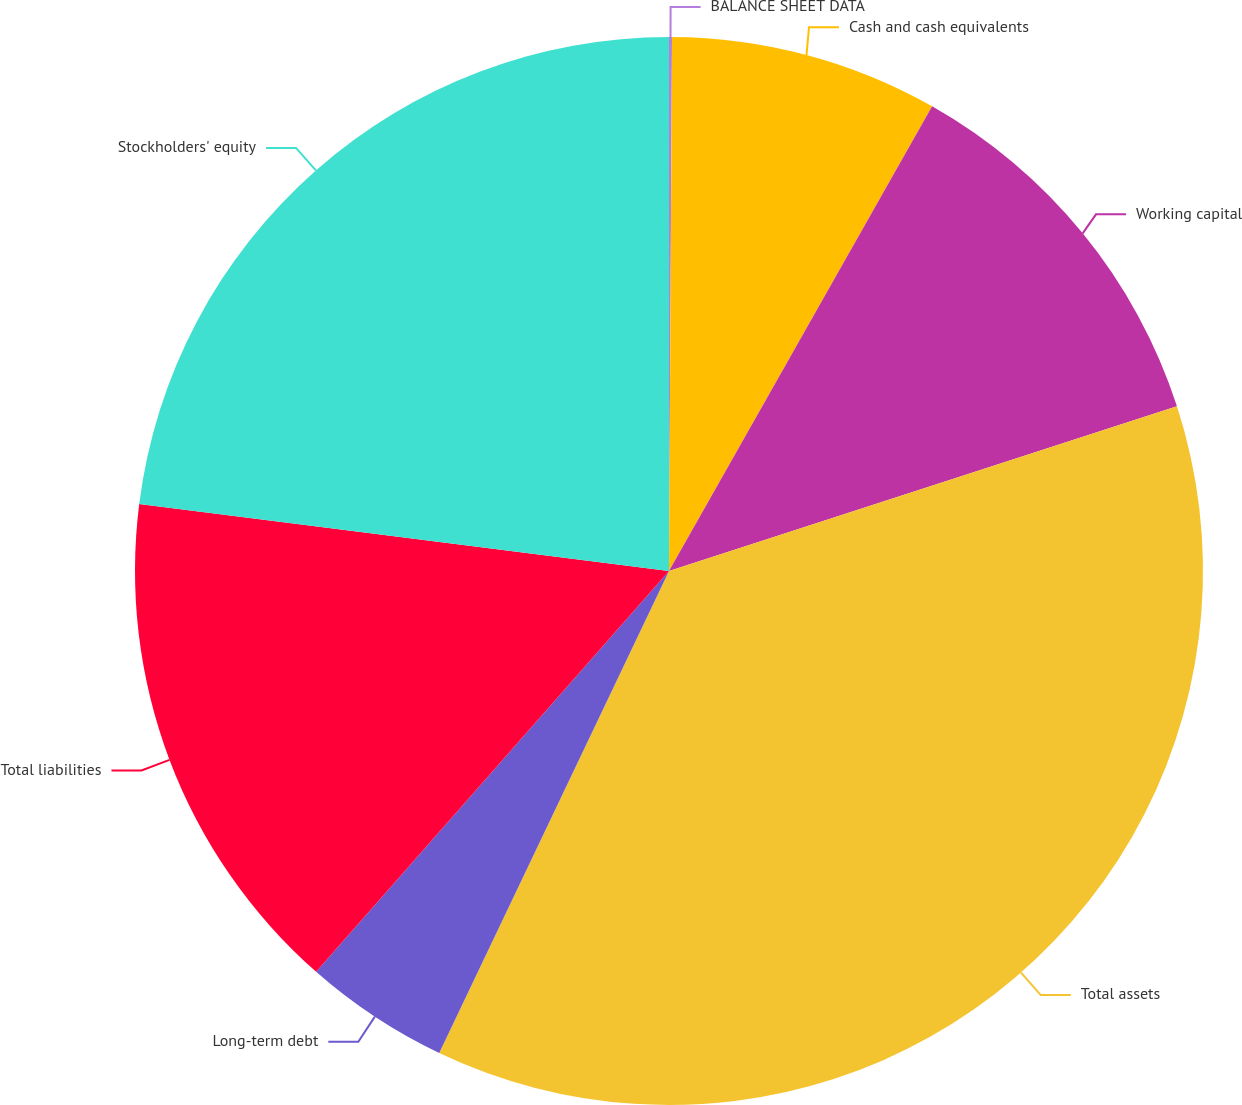Convert chart to OTSL. <chart><loc_0><loc_0><loc_500><loc_500><pie_chart><fcel>BALANCE SHEET DATA<fcel>Cash and cash equivalents<fcel>Working capital<fcel>Total assets<fcel>Long-term debt<fcel>Total liabilities<fcel>Stockholders' equity<nl><fcel>0.09%<fcel>8.11%<fcel>11.81%<fcel>37.07%<fcel>4.41%<fcel>15.51%<fcel>23.0%<nl></chart> 